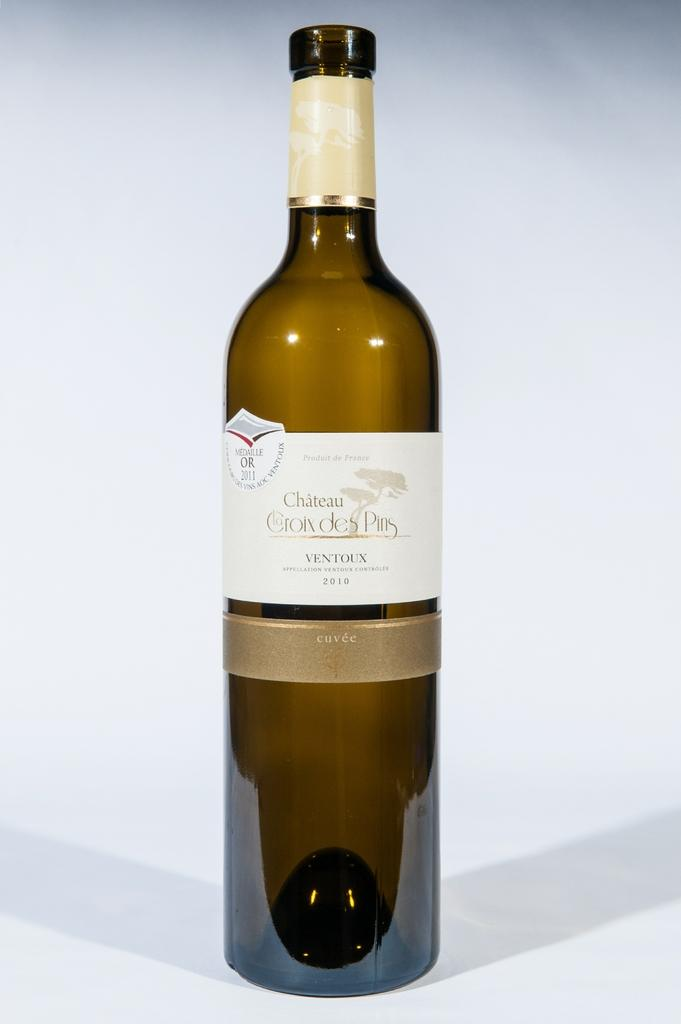Provide a one-sentence caption for the provided image. A bottle of wine has both the year 2010 and the year 2011 on its label. 